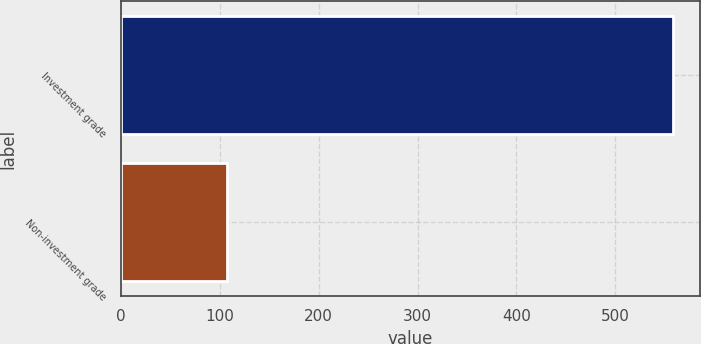<chart> <loc_0><loc_0><loc_500><loc_500><bar_chart><fcel>Investment grade<fcel>Non-investment grade<nl><fcel>558<fcel>107<nl></chart> 